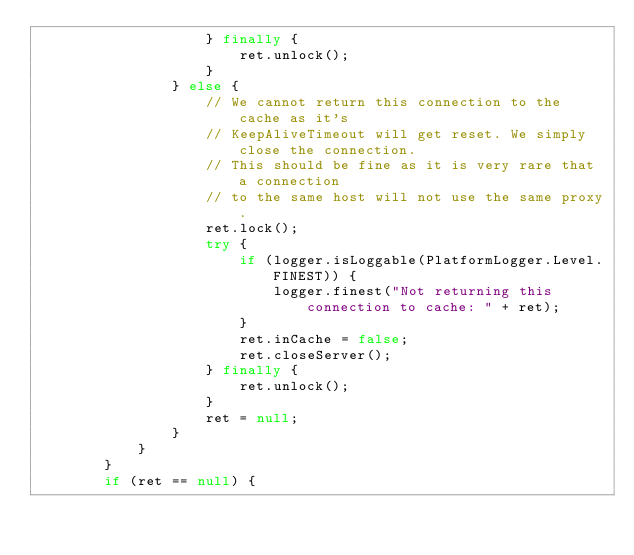Convert code to text. <code><loc_0><loc_0><loc_500><loc_500><_Java_>                    } finally {
                        ret.unlock();
                    }
                } else {
                    // We cannot return this connection to the cache as it's
                    // KeepAliveTimeout will get reset. We simply close the connection.
                    // This should be fine as it is very rare that a connection
                    // to the same host will not use the same proxy.
                    ret.lock();
                    try {
                        if (logger.isLoggable(PlatformLogger.Level.FINEST)) {
                            logger.finest("Not returning this connection to cache: " + ret);
                        }
                        ret.inCache = false;
                        ret.closeServer();
                    } finally {
                        ret.unlock();
                    }
                    ret = null;
                }
            }
        }
        if (ret == null) {</code> 